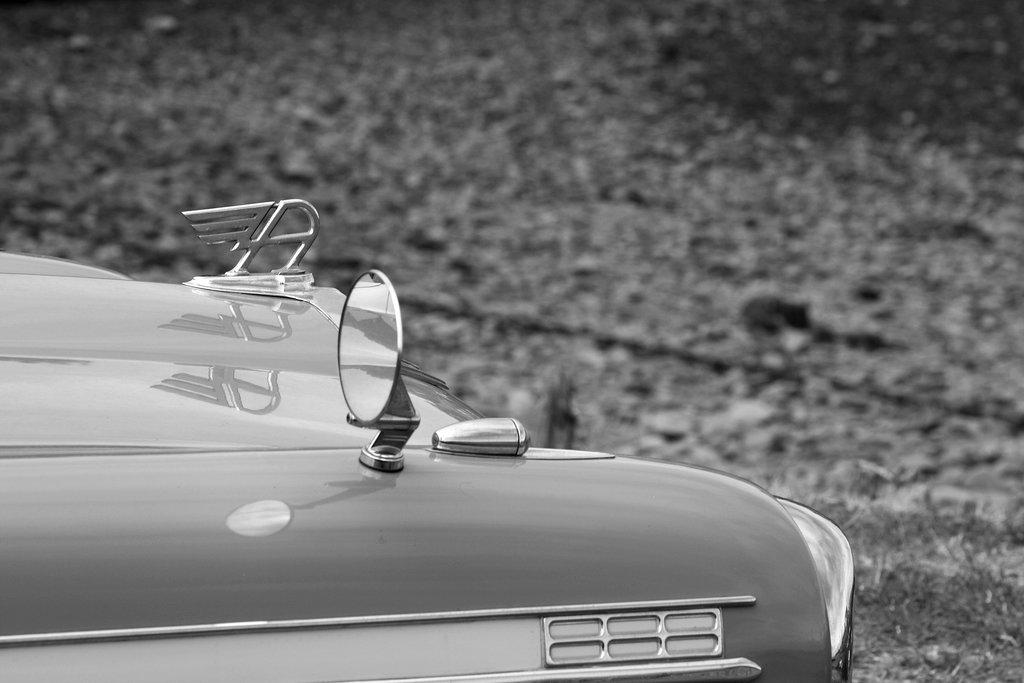What is the main subject of the picture? The main subject of the picture is a car. What specific feature can be seen on the car? The car has a mirror. Is there any branding or identification on the car? Yes, the car has a logo. What type of toy can be seen playing with the car in the image? There is no toy present in the image, and therefore no such activity can be observed. What kind of metal is used to construct the car in the image? The image does not provide information about the materials used to construct the car, so it cannot be determined from the picture. 